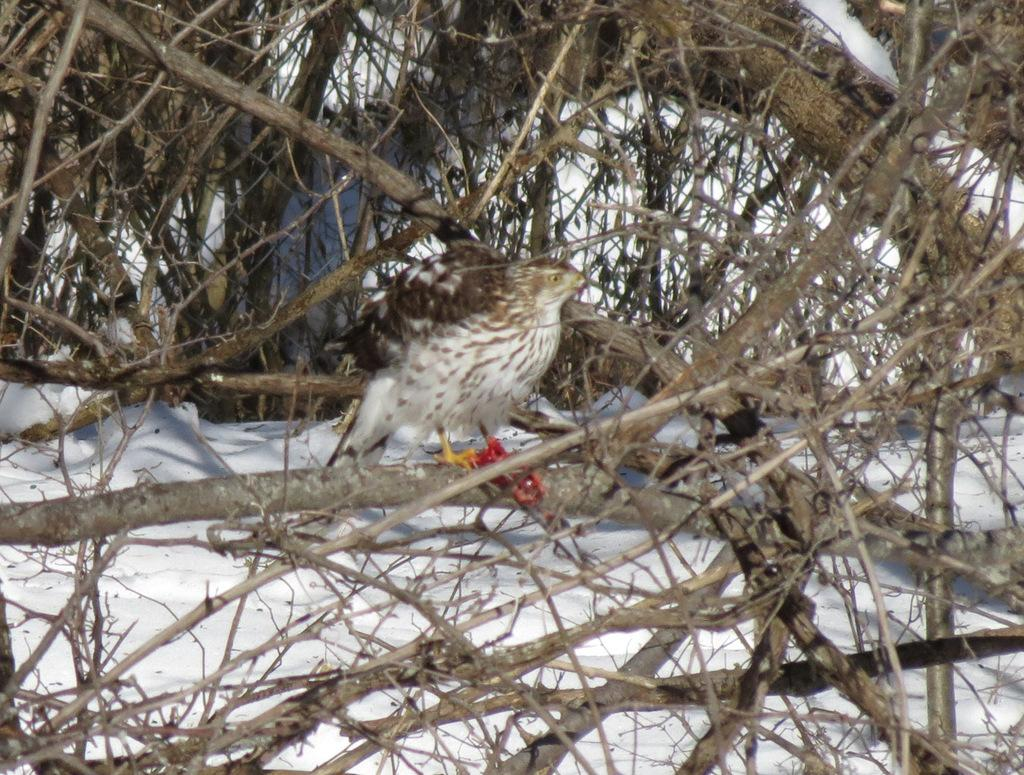What is the main subject in the middle of the image? There is a bird in the middle of the image. What type of environment is depicted in the image? There are many dry woods in the image. What can be seen in the background of the image? There is snow visible in the background of the image. What flavor of sand can be tasted in the image? There is no sand present in the image, so it cannot be tasted or have a flavor. 